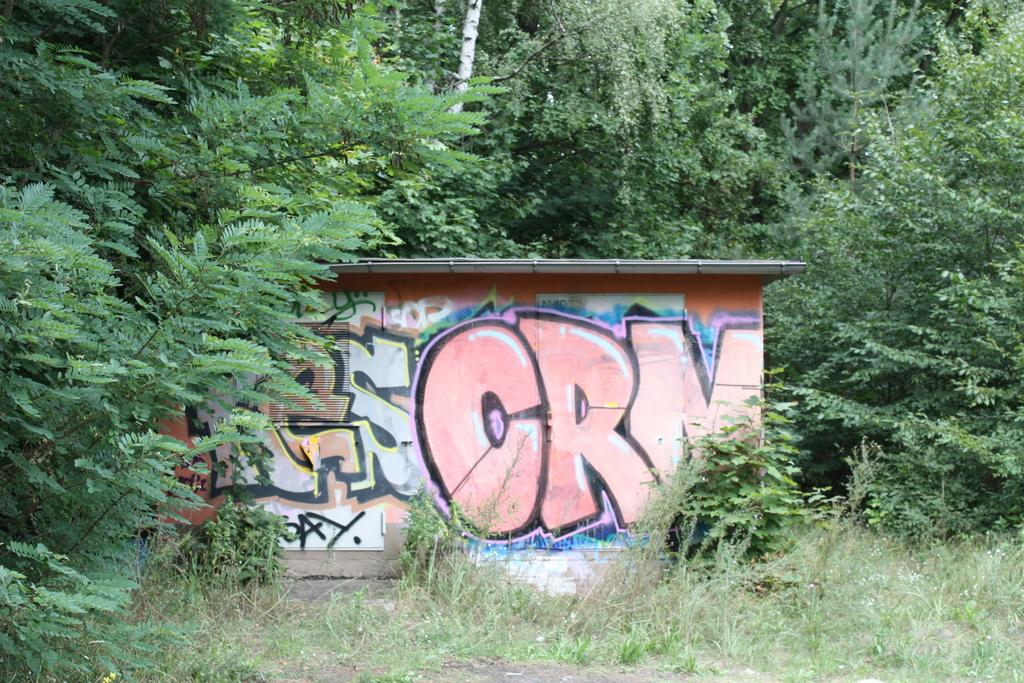What is present on the wall in the image? There is a painting on the wall in the image. What can be seen in the background of the image? There are trees in the background of the image. What type of rifle is hanging on the wall in the image? There is no rifle present in the image; it only features a wall and a painting. 